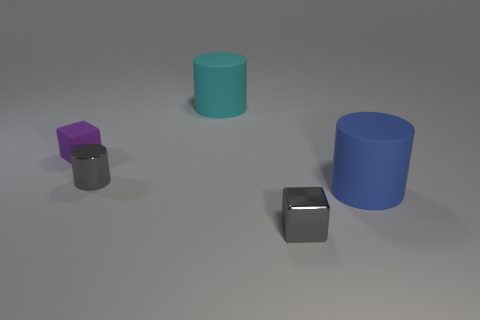Is the metal cylinder the same color as the metallic block?
Ensure brevity in your answer.  Yes. What number of small green metallic things are the same shape as the tiny rubber object?
Make the answer very short. 0. Do the small gray cylinder and the tiny gray object in front of the gray metallic cylinder have the same material?
Your response must be concise. Yes. There is a purple cube that is the same size as the gray metal cube; what is it made of?
Provide a succinct answer. Rubber. Are there any matte things of the same size as the gray cylinder?
Provide a short and direct response. Yes. There is another matte object that is the same size as the blue matte object; what is its shape?
Your answer should be very brief. Cylinder. How many other objects are the same color as the metal cylinder?
Offer a very short reply. 1. The rubber object that is in front of the big cyan cylinder and left of the tiny shiny block has what shape?
Provide a short and direct response. Cube. Is there a cylinder in front of the small thing behind the small gray object left of the cyan rubber cylinder?
Provide a short and direct response. Yes. How many other objects are the same material as the gray cube?
Provide a succinct answer. 1. 